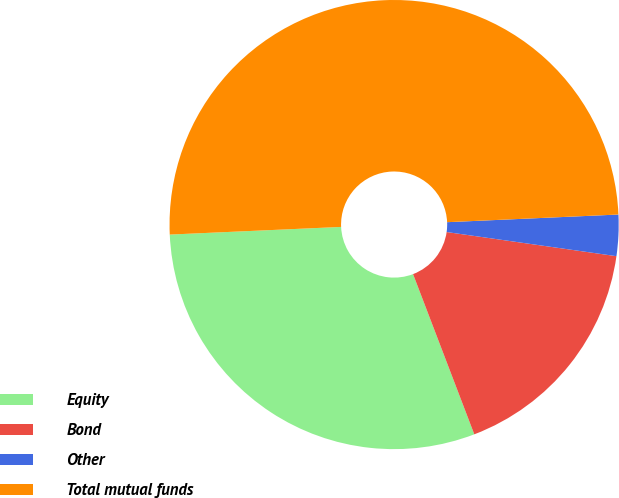<chart> <loc_0><loc_0><loc_500><loc_500><pie_chart><fcel>Equity<fcel>Bond<fcel>Other<fcel>Total mutual funds<nl><fcel>30.1%<fcel>16.94%<fcel>2.96%<fcel>50.0%<nl></chart> 